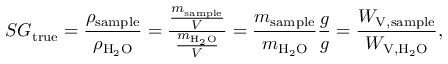Convert formula to latex. <formula><loc_0><loc_0><loc_500><loc_500>S G _ { t r u e } = { \frac { \rho _ { s a m p l e } } { \rho _ { H _ { 2 } O } } } = { \frac { \frac { m _ { s a m p l e } } { V } } { \frac { m _ { H _ { 2 } O } } { V } } } = { \frac { m _ { s a m p l e } } { m _ { H _ { 2 } O } } } { \frac { g } { g } } = { \frac { W _ { V , { s a m p l e } } } { W _ { V , H _ { 2 } O } } } ,</formula> 